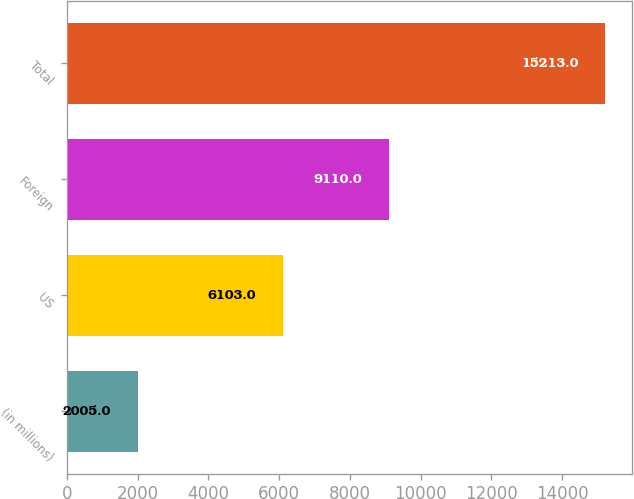Convert chart to OTSL. <chart><loc_0><loc_0><loc_500><loc_500><bar_chart><fcel>(in millions)<fcel>US<fcel>Foreign<fcel>Total<nl><fcel>2005<fcel>6103<fcel>9110<fcel>15213<nl></chart> 